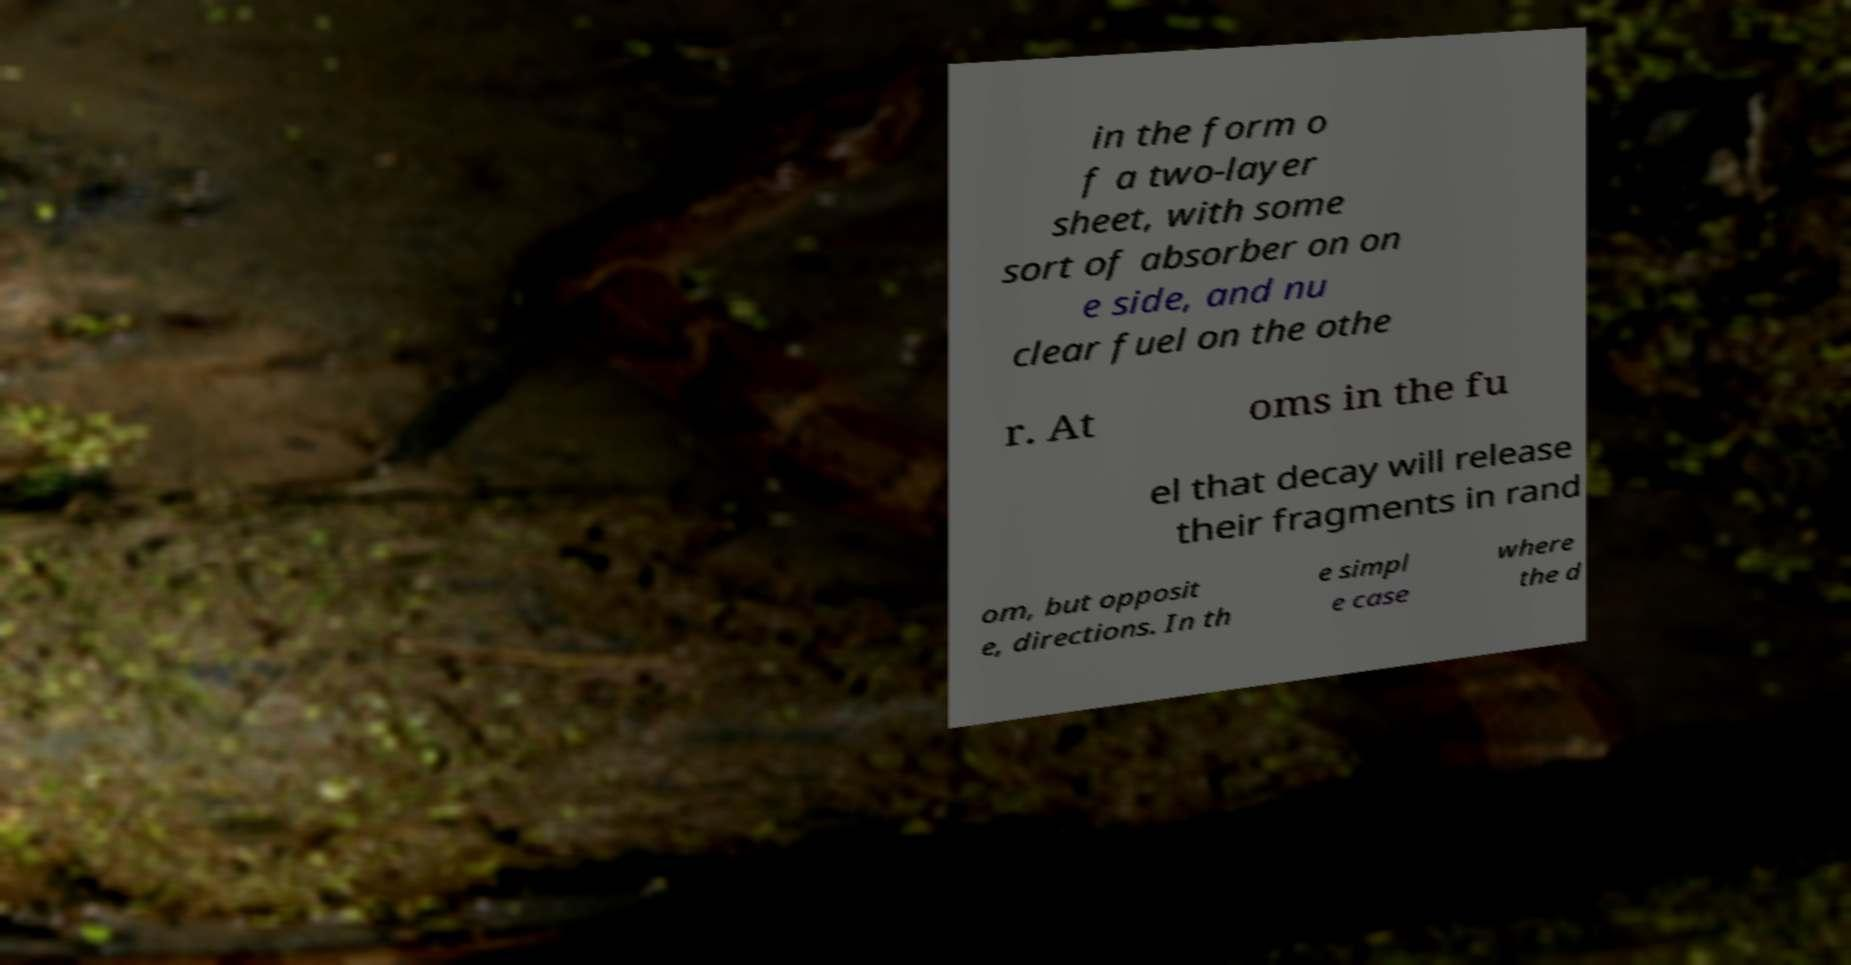There's text embedded in this image that I need extracted. Can you transcribe it verbatim? in the form o f a two-layer sheet, with some sort of absorber on on e side, and nu clear fuel on the othe r. At oms in the fu el that decay will release their fragments in rand om, but opposit e, directions. In th e simpl e case where the d 